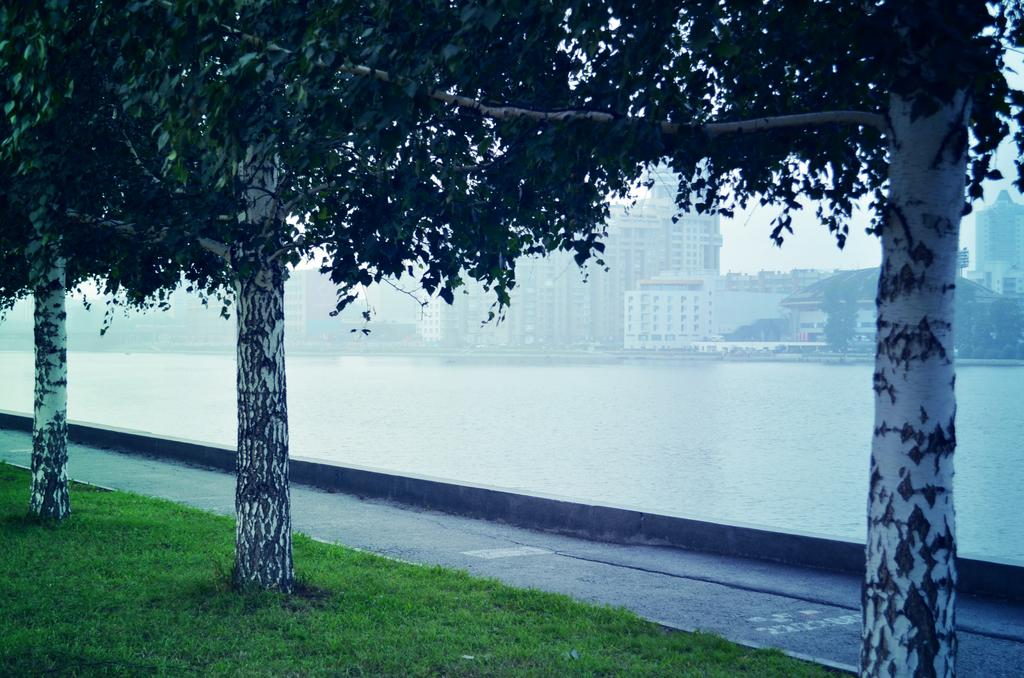What type of vegetation is present in the image? There is a group of trees in the image. What type of ground cover can be seen in the image? There is grass in the image. What natural feature is visible in the image? There is a large water body in the image. What type of man-made structures are present in the image? There is a group of buildings in the image. What is visible in the background of the image? The sky is visible in the image. Can you see any bones sticking out of the water in the image? There are no bones visible in the image; it features a group of trees, grass, a large water body, a group of buildings, and the sky. What type of amphibian can be seen sitting on the grass in the image? There are no amphibians, such as toads, present in the image. 